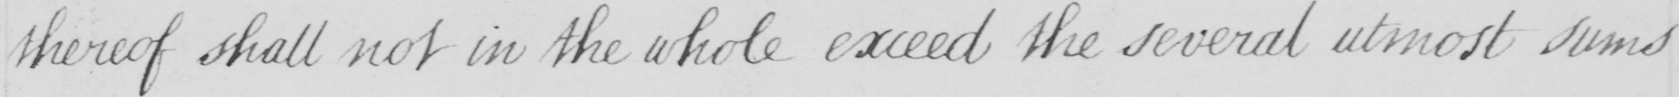Can you tell me what this handwritten text says? thereof shall not in the whole exceed the several utmost sums 